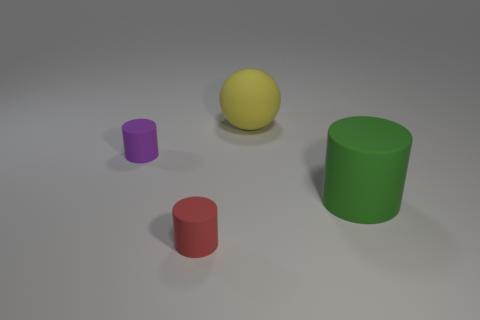The matte object that is behind the big green rubber cylinder and in front of the yellow thing has what shape?
Keep it short and to the point. Cylinder. Are there any purple matte cylinders of the same size as the ball?
Offer a terse response. No. There is a big matte cylinder; is it the same color as the small matte object that is behind the small red thing?
Provide a short and direct response. No. What material is the yellow ball?
Provide a succinct answer. Rubber. What color is the cylinder to the right of the red rubber thing?
Give a very brief answer. Green. How many other balls have the same color as the large rubber sphere?
Make the answer very short. 0. How many large rubber things are both behind the small purple matte cylinder and on the right side of the large ball?
Ensure brevity in your answer.  0. The other thing that is the same size as the red matte object is what shape?
Make the answer very short. Cylinder. What is the size of the sphere?
Ensure brevity in your answer.  Large. The small cylinder that is behind the small matte object in front of the rubber cylinder that is on the right side of the red cylinder is made of what material?
Offer a terse response. Rubber. 